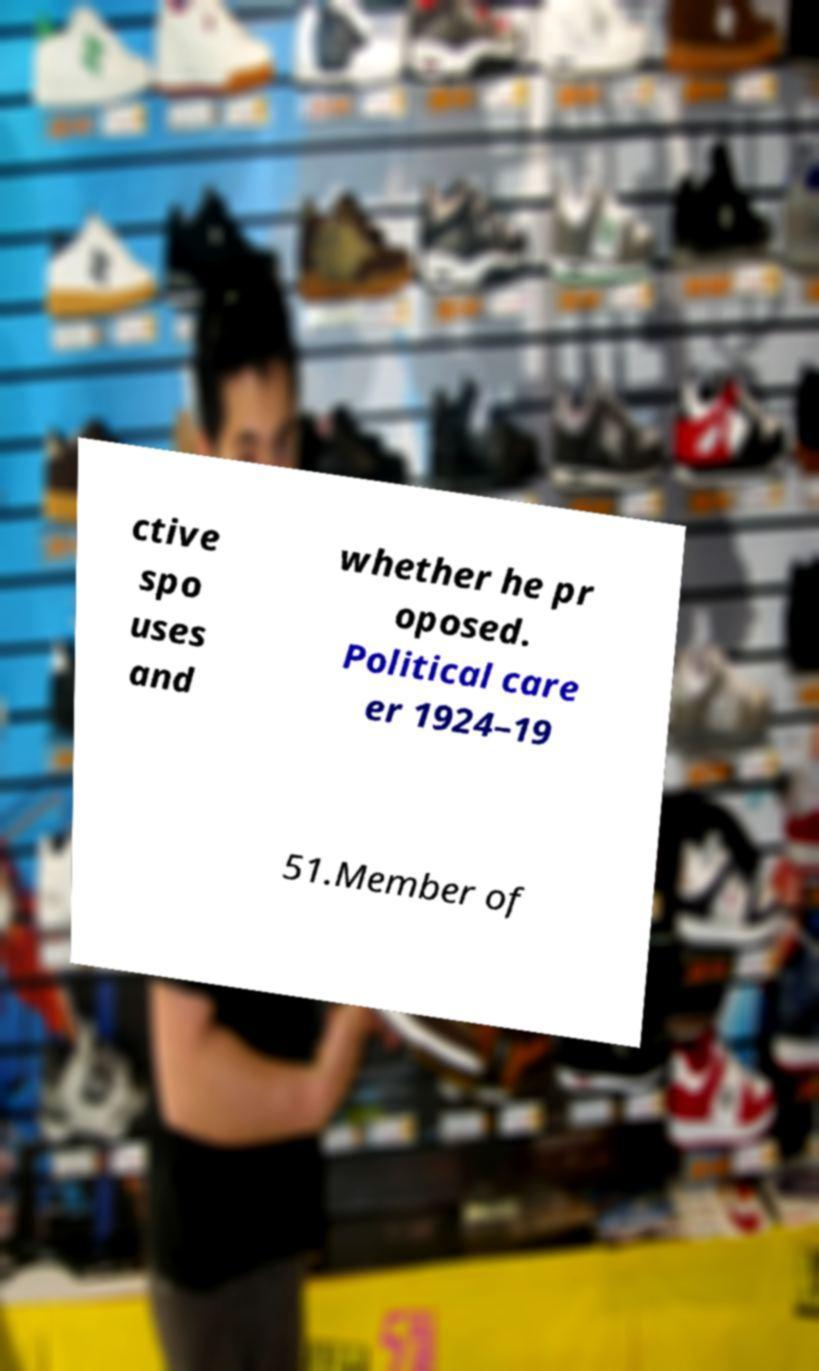Could you assist in decoding the text presented in this image and type it out clearly? ctive spo uses and whether he pr oposed. Political care er 1924–19 51.Member of 